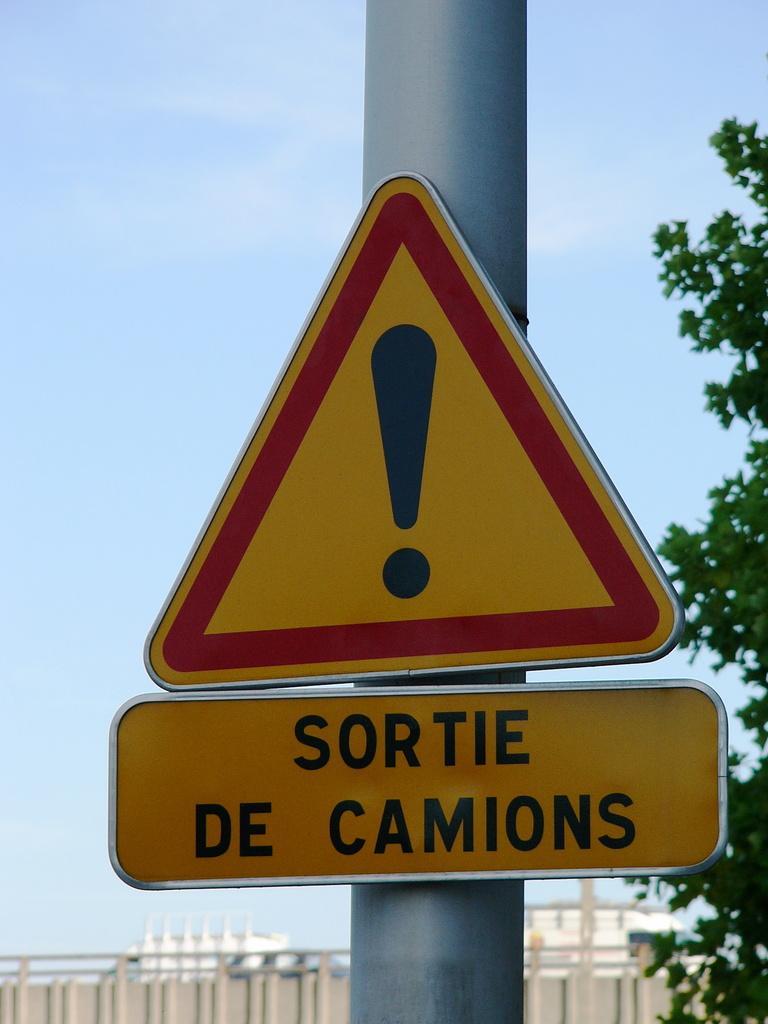Please provide a concise description of this image. In the given image i can see a fence,trees,pole,board with some text and in the background i can see the sky. 